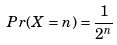Convert formula to latex. <formula><loc_0><loc_0><loc_500><loc_500>P r ( X = n ) = \frac { 1 } { 2 ^ { n } }</formula> 